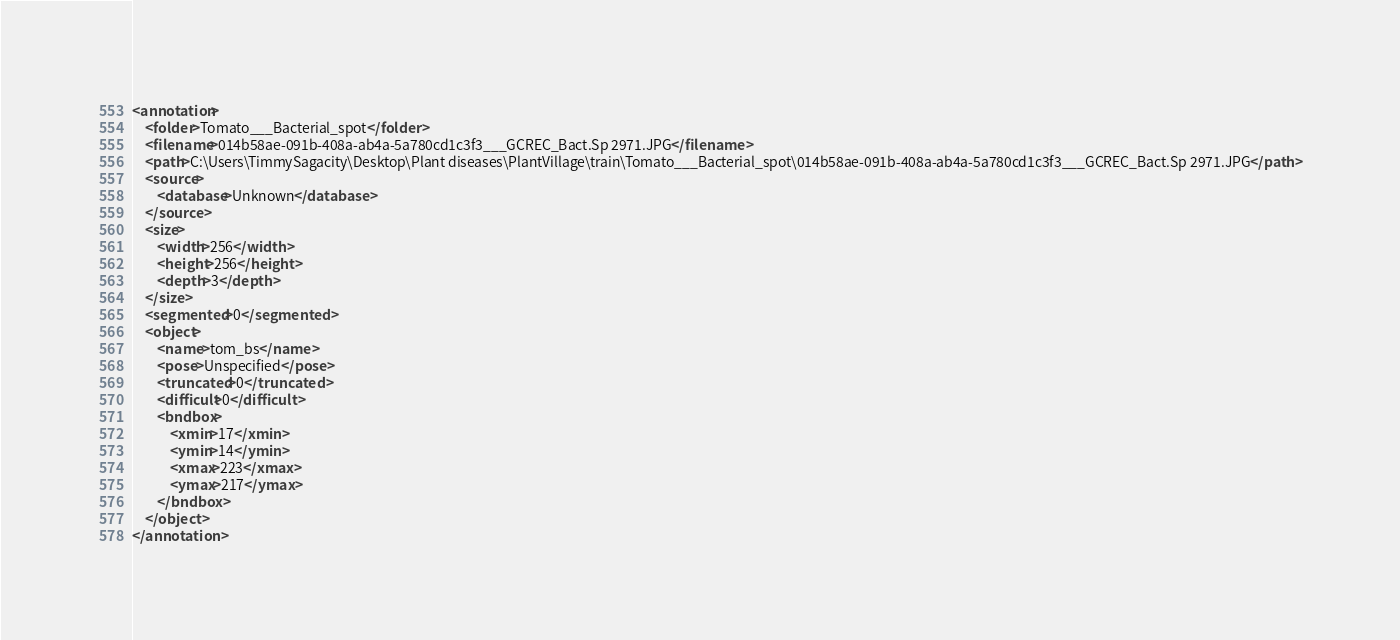<code> <loc_0><loc_0><loc_500><loc_500><_XML_><annotation>
	<folder>Tomato___Bacterial_spot</folder>
	<filename>014b58ae-091b-408a-ab4a-5a780cd1c3f3___GCREC_Bact.Sp 2971.JPG</filename>
	<path>C:\Users\TimmySagacity\Desktop\Plant diseases\PlantVillage\train\Tomato___Bacterial_spot\014b58ae-091b-408a-ab4a-5a780cd1c3f3___GCREC_Bact.Sp 2971.JPG</path>
	<source>
		<database>Unknown</database>
	</source>
	<size>
		<width>256</width>
		<height>256</height>
		<depth>3</depth>
	</size>
	<segmented>0</segmented>
	<object>
		<name>tom_bs</name>
		<pose>Unspecified</pose>
		<truncated>0</truncated>
		<difficult>0</difficult>
		<bndbox>
			<xmin>17</xmin>
			<ymin>14</ymin>
			<xmax>223</xmax>
			<ymax>217</ymax>
		</bndbox>
	</object>
</annotation>
</code> 